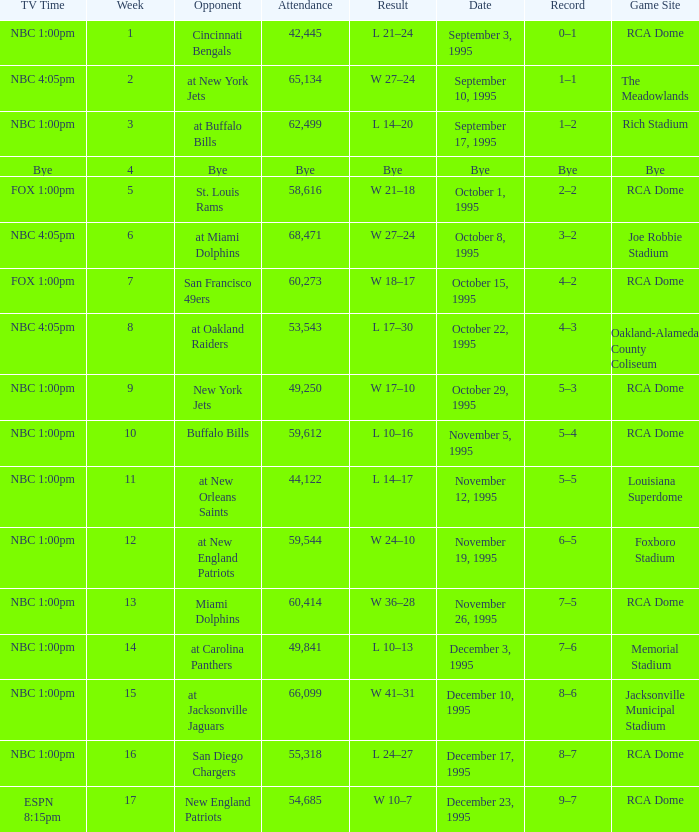What's the Opponent with a Week that's larger than 16? New England Patriots. 